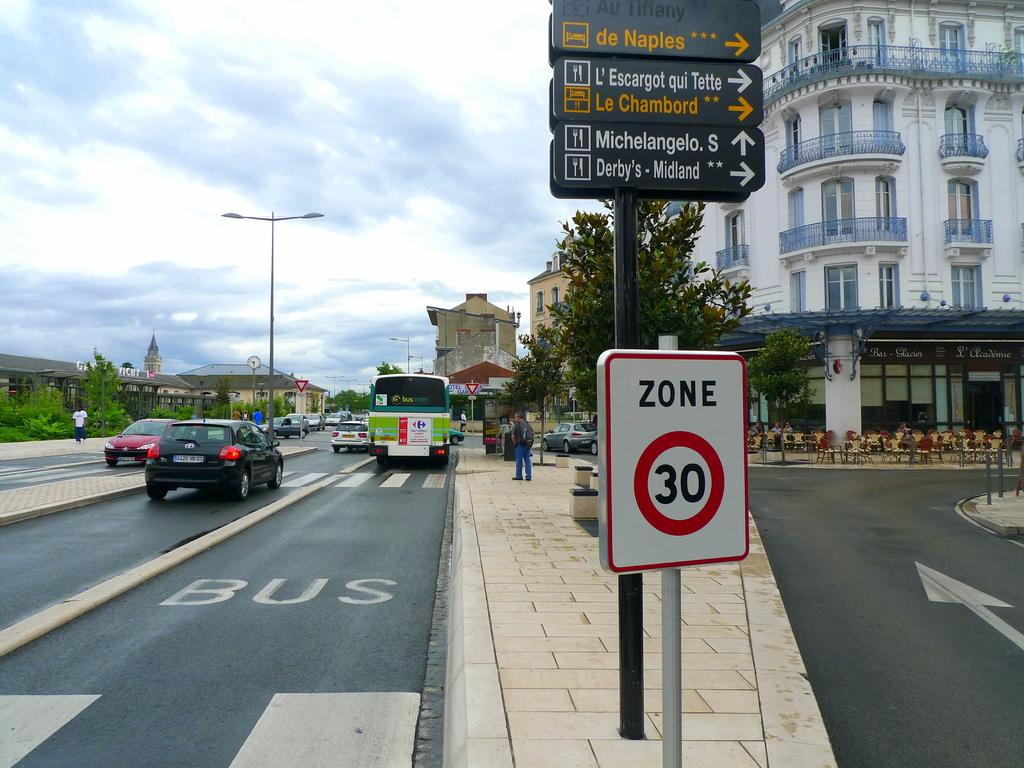What can be seen on the sign boards in the image? The content of the sign boards cannot be determined from the image. What types of vehicles are on the road in the image? The specific types of vehicles cannot be determined from the image. What are the people in the image doing? The actions of the people in the image cannot be determined from the image. What are the poles used for in the image? The purpose of the poles cannot be determined from the image. What type of trees are in the image? The specific type of trees cannot be determined from the image. What kind of buildings are in the image? The specific types of buildings cannot be determined from the image. What verse from the minister's speech can be heard in the image? There is no minister or speech present in the image, so no verse can be heard. What type of pear is being used as a decoration in the image? There is no pear present in the image. 